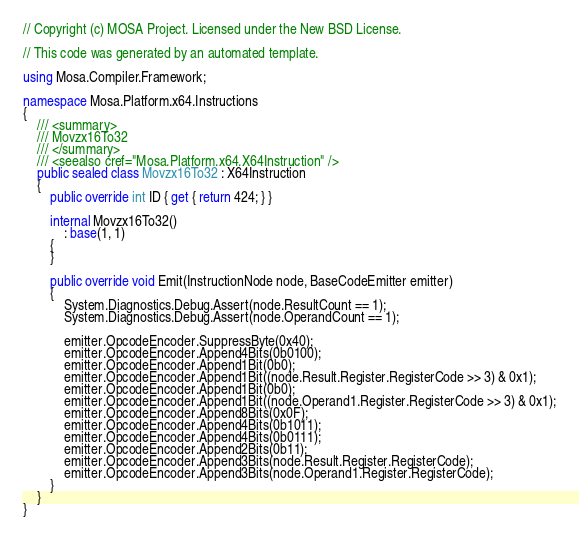Convert code to text. <code><loc_0><loc_0><loc_500><loc_500><_C#_>// Copyright (c) MOSA Project. Licensed under the New BSD License.

// This code was generated by an automated template.

using Mosa.Compiler.Framework;

namespace Mosa.Platform.x64.Instructions
{
	/// <summary>
	/// Movzx16To32
	/// </summary>
	/// <seealso cref="Mosa.Platform.x64.X64Instruction" />
	public sealed class Movzx16To32 : X64Instruction
	{
		public override int ID { get { return 424; } }

		internal Movzx16To32()
			: base(1, 1)
		{
		}

		public override void Emit(InstructionNode node, BaseCodeEmitter emitter)
		{
			System.Diagnostics.Debug.Assert(node.ResultCount == 1);
			System.Diagnostics.Debug.Assert(node.OperandCount == 1);

			emitter.OpcodeEncoder.SuppressByte(0x40);
			emitter.OpcodeEncoder.Append4Bits(0b0100);
			emitter.OpcodeEncoder.Append1Bit(0b0);
			emitter.OpcodeEncoder.Append1Bit((node.Result.Register.RegisterCode >> 3) & 0x1);
			emitter.OpcodeEncoder.Append1Bit(0b0);
			emitter.OpcodeEncoder.Append1Bit((node.Operand1.Register.RegisterCode >> 3) & 0x1);
			emitter.OpcodeEncoder.Append8Bits(0x0F);
			emitter.OpcodeEncoder.Append4Bits(0b1011);
			emitter.OpcodeEncoder.Append4Bits(0b0111);
			emitter.OpcodeEncoder.Append2Bits(0b11);
			emitter.OpcodeEncoder.Append3Bits(node.Result.Register.RegisterCode);
			emitter.OpcodeEncoder.Append3Bits(node.Operand1.Register.RegisterCode);
		}
	}
}
</code> 